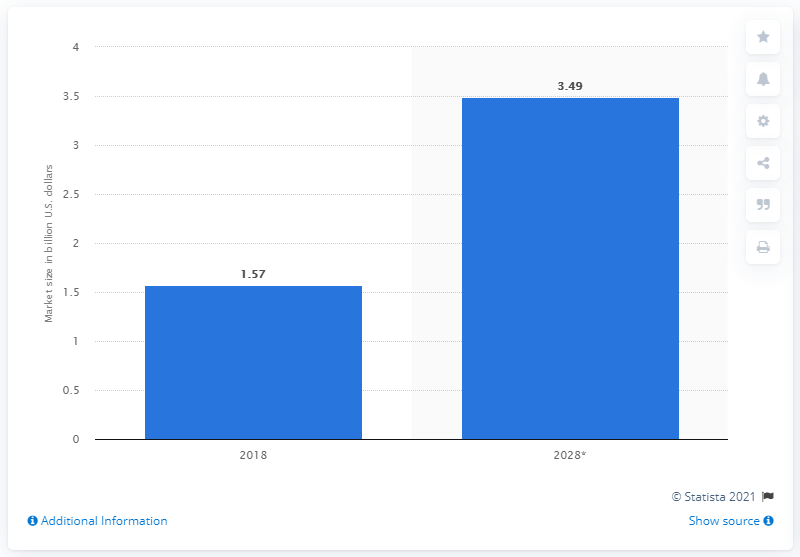Specify some key components in this picture. In 2018, the market size for CDSS was estimated to be 1.57... In the year 2018, the global CDSS market was established. 